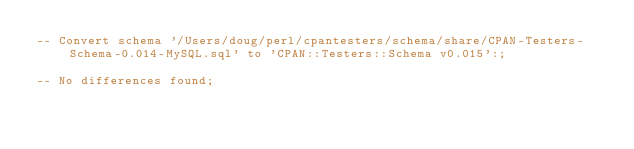<code> <loc_0><loc_0><loc_500><loc_500><_SQL_>-- Convert schema '/Users/doug/perl/cpantesters/schema/share/CPAN-Testers-Schema-0.014-MySQL.sql' to 'CPAN::Testers::Schema v0.015':;

-- No differences found;

</code> 